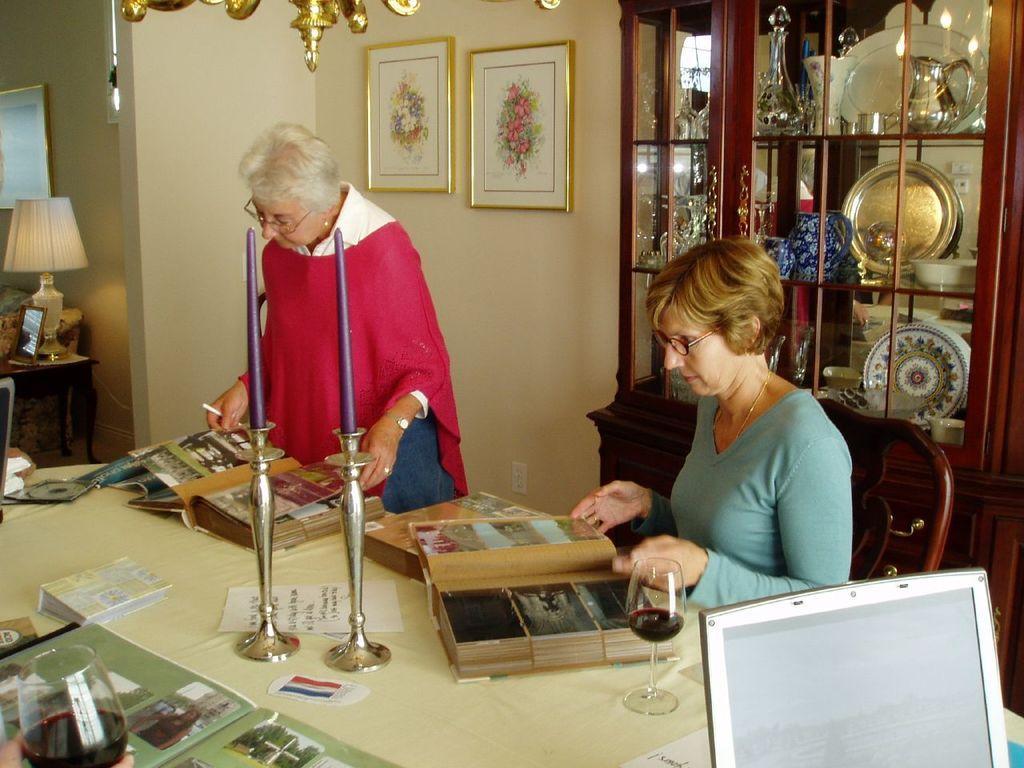Can you describe this image briefly? In this picture we can see two woman where one is sitting on chair and other is standing looking at books placed on table and we have papers, CD, glass with drink in it, laptop on table and in background we can see wall with frames, cupboards, lamp. 